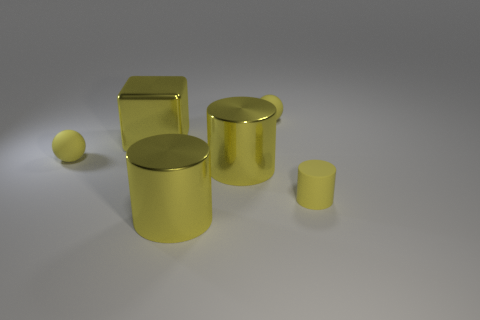Subtract all yellow balls. How many were subtracted if there are1yellow balls left? 1 Subtract all small cylinders. How many cylinders are left? 2 Subtract 1 cylinders. How many cylinders are left? 2 Add 3 small yellow things. How many objects exist? 9 Subtract all gray cylinders. Subtract all brown spheres. How many cylinders are left? 3 Subtract all spheres. How many objects are left? 4 Add 3 rubber cylinders. How many rubber cylinders exist? 4 Subtract 0 brown cylinders. How many objects are left? 6 Subtract all yellow metallic cylinders. Subtract all large yellow cylinders. How many objects are left? 2 Add 5 metallic objects. How many metallic objects are left? 8 